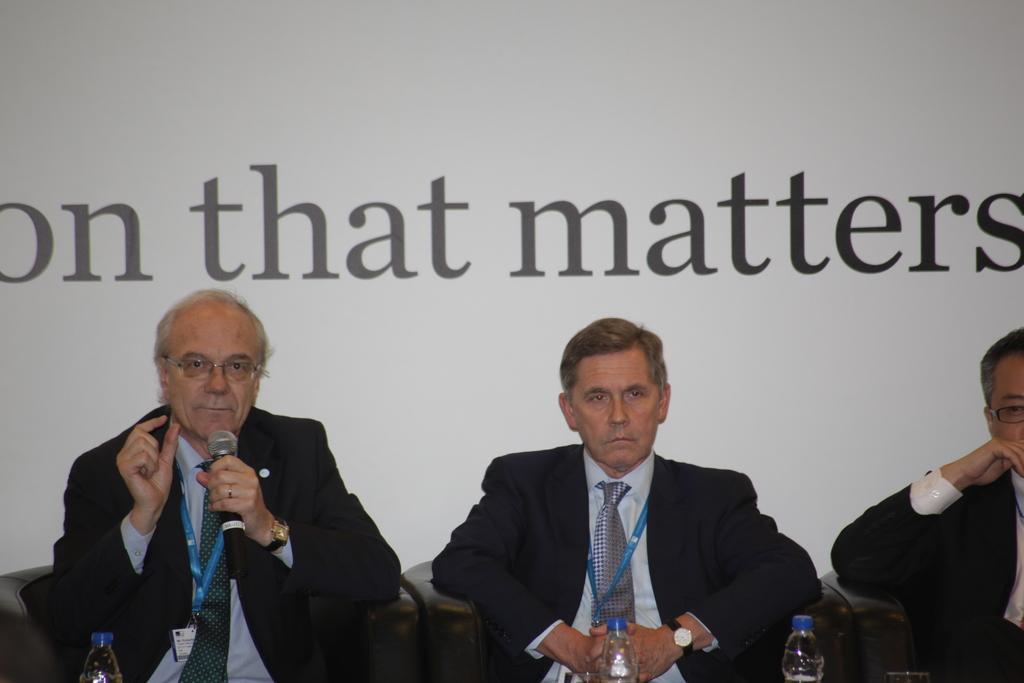How would you summarize this image in a sentence or two? In the picture I can see three men sitting on the sofas and I can see one of them speaking on a microphone. I can see three of them wearing a suit and tie. There is a tag on their neck. I can see the water bottles at the bottom of the picture. It is looking like a text on the screen in the background. 